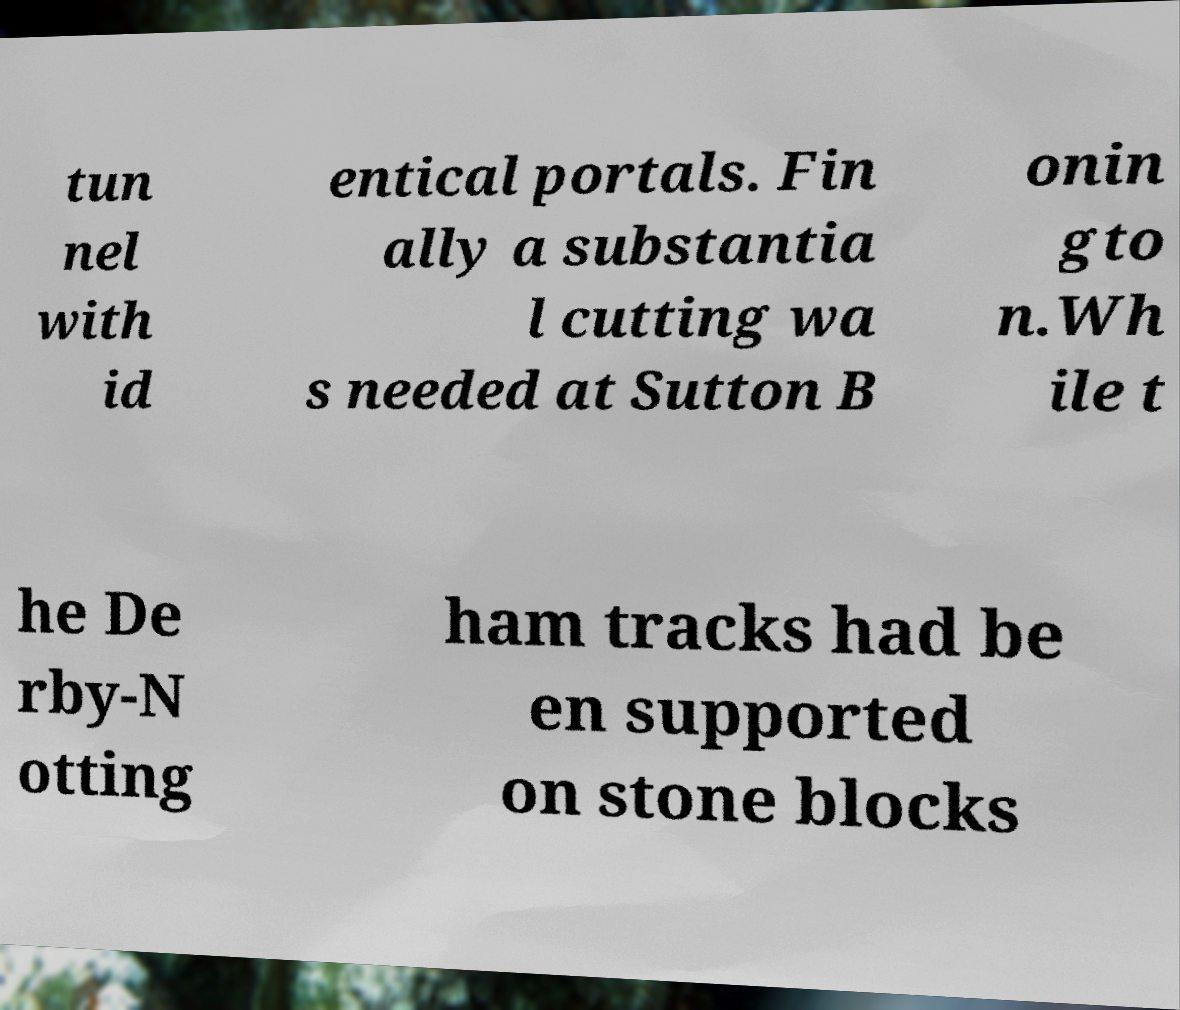Please identify and transcribe the text found in this image. tun nel with id entical portals. Fin ally a substantia l cutting wa s needed at Sutton B onin gto n.Wh ile t he De rby-N otting ham tracks had be en supported on stone blocks 